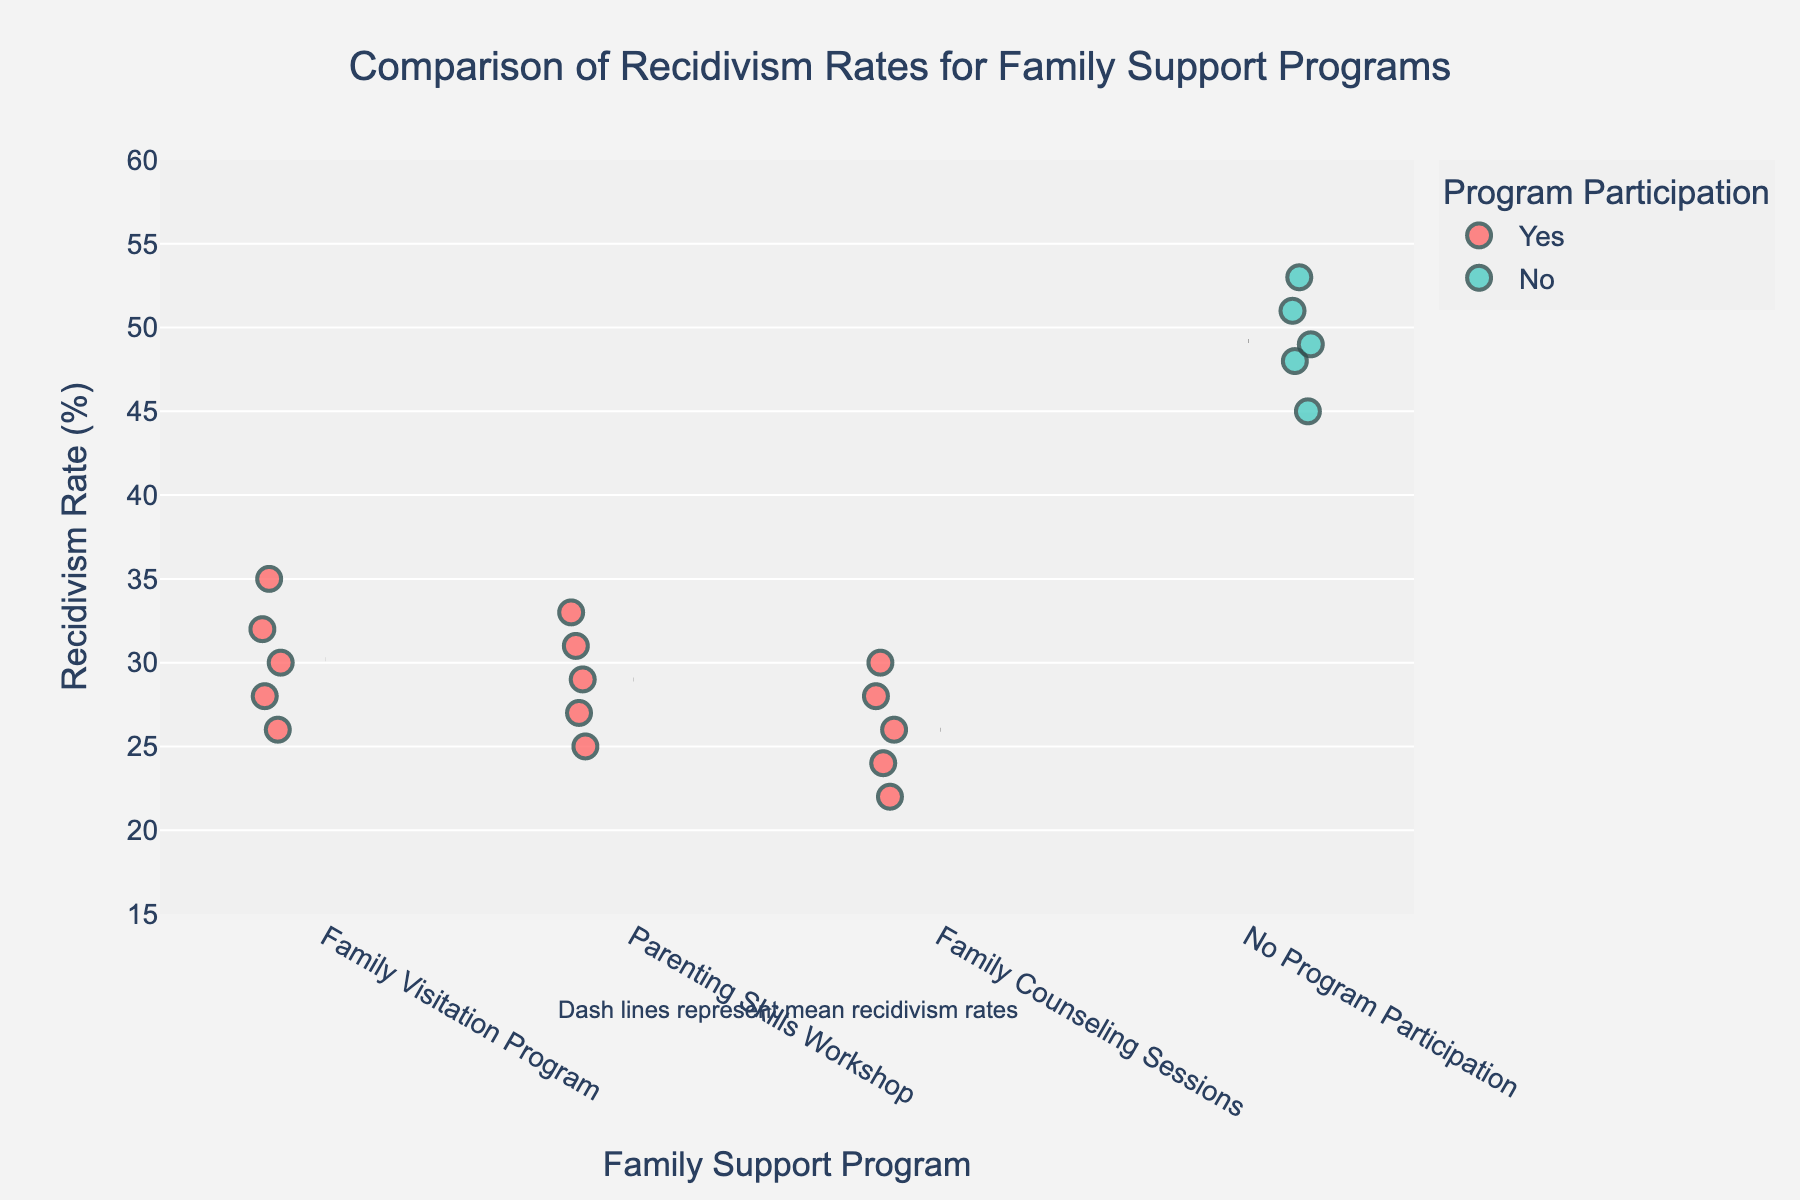How many family support programs are included in the visualization? The figure shows data categorized under different family support programs. By counting the distinct labels on the x-axis, we can identify that there are three family support programs: Family Visitation Program, Parenting Skills Workshop, and Family Counseling Sessions.
Answer: Three What is the range of recidivism rates for inmates participating in the Family Counseling Sessions? The recidivism rates for the Family Counseling Sessions vary from the minimum data point (22%) to the maximum data point (30%).
Answer: 22%-30% Which program shows the highest average recidivism rate? By observing the dashed lines representing mean recidivism rates for each program, we can identify that the "No Program Participation" group has the highest average recidivism rate among all the programs.
Answer: No Program Participation By roughly how much does the average recidivism rate differ between those who participated in the Family Visitation Program and those who did not participate in any program? First, we identify the mean recidivism rates for both the Family Visitation Program and No Program Participation from the dashed lines. The figure shows that the Family Visitation Program has an average around 30%, while the No Program Participation group has an average around 49%. The difference is approximately 49% - 30% = 19%.
Answer: 19% Based solely on the figure, which family support program has the lowest individual recidivism rate recorded, and what is that rate? The lowest individual recidivism rate is found in the Family Counseling Sessions program, where the lowest point is 22%.
Answer: Family Counseling Sessions, 22% How does participation in family support programs overall affect recidivism rates in comparison to non-participation, as shown in the visualization? Comparing the clustered points and their respective mean lines, it is clear that all three family support programs (Family Visitation Program, Parenting Skills Workshop, and Family Counseling Sessions) have lower recidivism rates than the No Program Participation category.
Answer: Family support programs lower recidivism rates How many individual data points are plotted for each family support program, and how does this compare to those not in any program? Count the number of points displayed for each category on the x-axis. Each family support program (Family Visitation Program, Parenting Skills Workshop, Family Counseling Sessions) has five data points, while the No Program Participation category also has five data points.
Answer: Five each Does the Visualization specify the exact recidivism rates for each data point? By examining the figure, it is evident that individual points (represented as dots) display the distribution of data but do not specify the exact recidivism rates without hovering or additional data reference.
Answer: No Which family support program has data points closest to the 50% recidivism rate, and are there any points above this rate? Observing the positions of the data points on the y-axis relative to the 50% mark, we see that none of the family support program categories have data points near or above the 50% recidivism rate. Only the No Program Participation group approaches and surpasses this level.
Answer: No Program Participation, Yes 